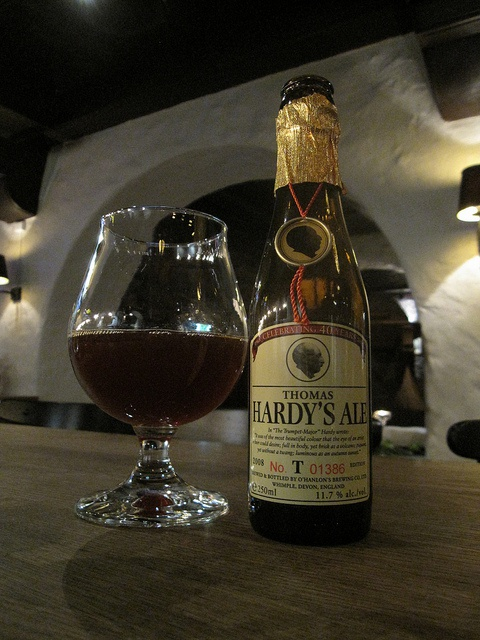Describe the objects in this image and their specific colors. I can see dining table in black and gray tones, bottle in black, olive, tan, and maroon tones, wine glass in black and gray tones, and chair in black and purple tones in this image. 